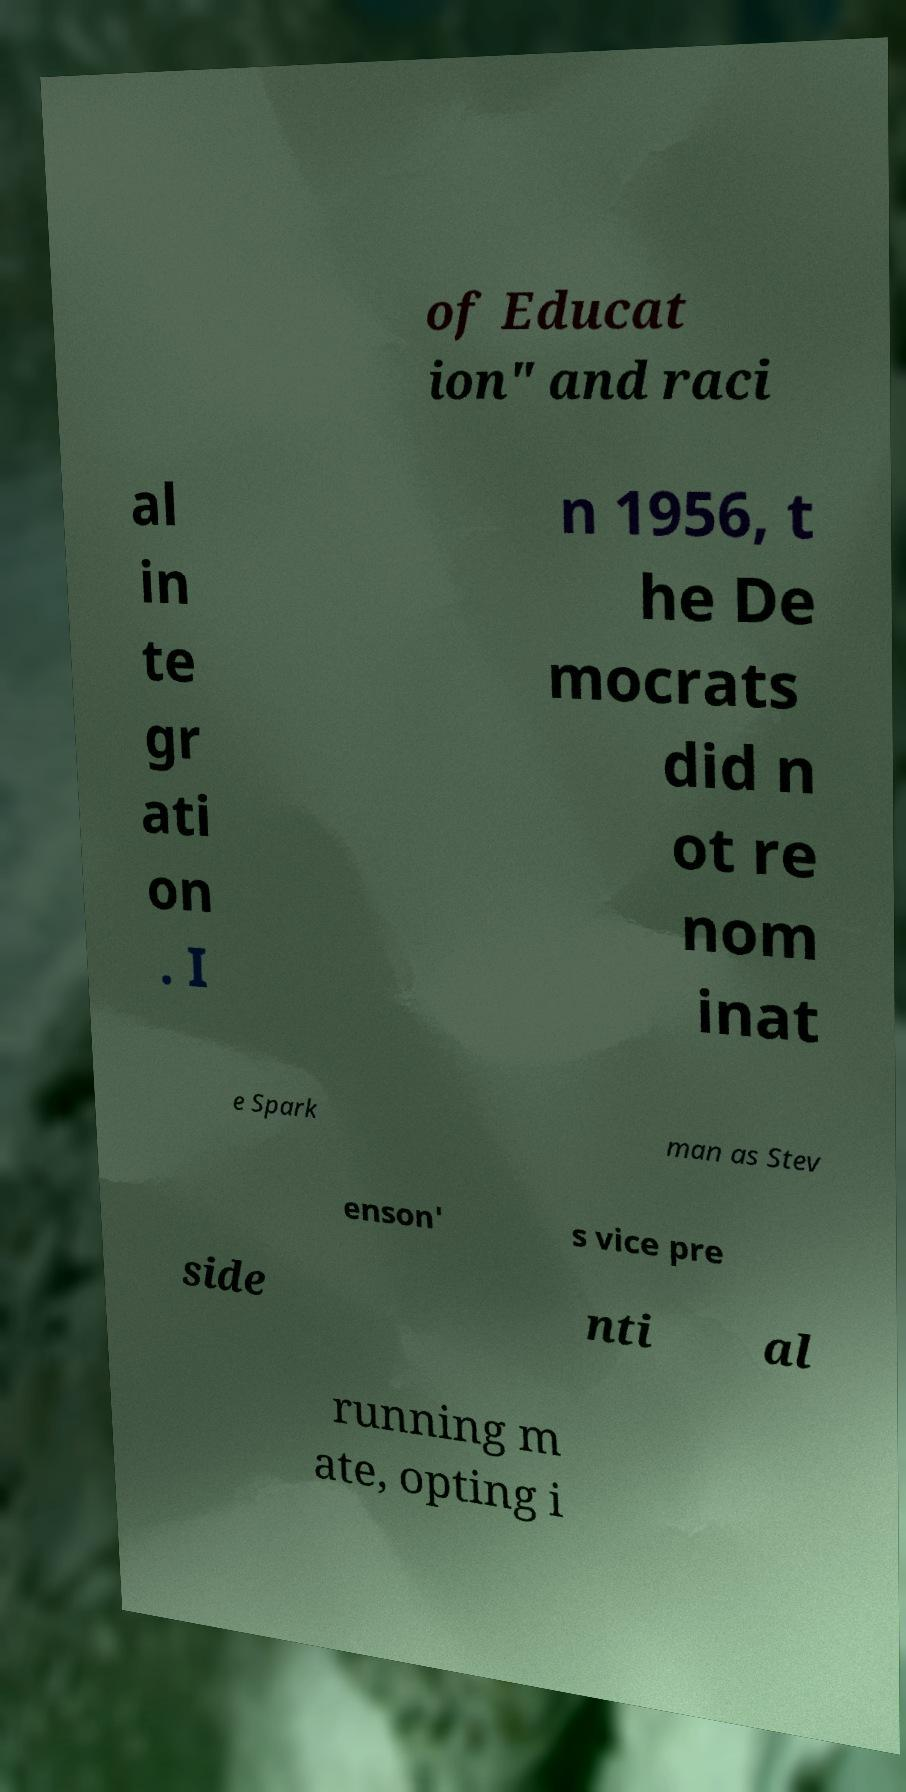For documentation purposes, I need the text within this image transcribed. Could you provide that? of Educat ion" and raci al in te gr ati on . I n 1956, t he De mocrats did n ot re nom inat e Spark man as Stev enson' s vice pre side nti al running m ate, opting i 